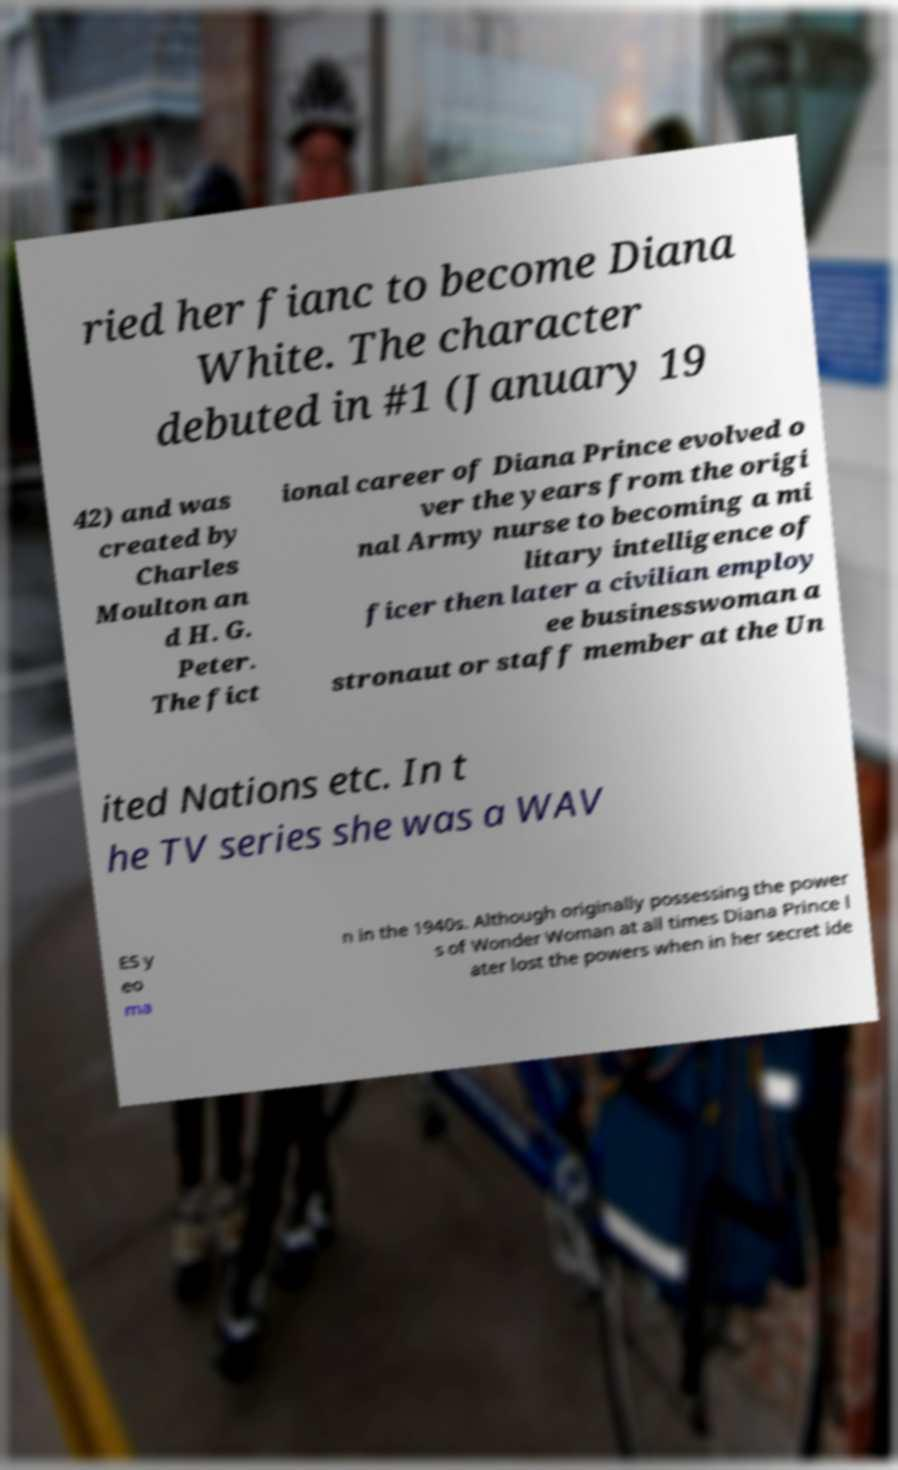Can you accurately transcribe the text from the provided image for me? ried her fianc to become Diana White. The character debuted in #1 (January 19 42) and was created by Charles Moulton an d H. G. Peter. The fict ional career of Diana Prince evolved o ver the years from the origi nal Army nurse to becoming a mi litary intelligence of ficer then later a civilian employ ee businesswoman a stronaut or staff member at the Un ited Nations etc. In t he TV series she was a WAV ES y eo ma n in the 1940s. Although originally possessing the power s of Wonder Woman at all times Diana Prince l ater lost the powers when in her secret ide 